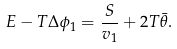Convert formula to latex. <formula><loc_0><loc_0><loc_500><loc_500>E - T \Delta \phi _ { 1 } = \frac { S } { v _ { 1 } } + 2 T \bar { \theta } .</formula> 